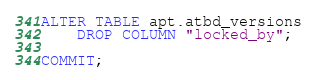Convert code to text. <code><loc_0><loc_0><loc_500><loc_500><_SQL_>
ALTER TABLE apt.atbd_versions
    DROP COLUMN "locked_by";

COMMIT;
</code> 